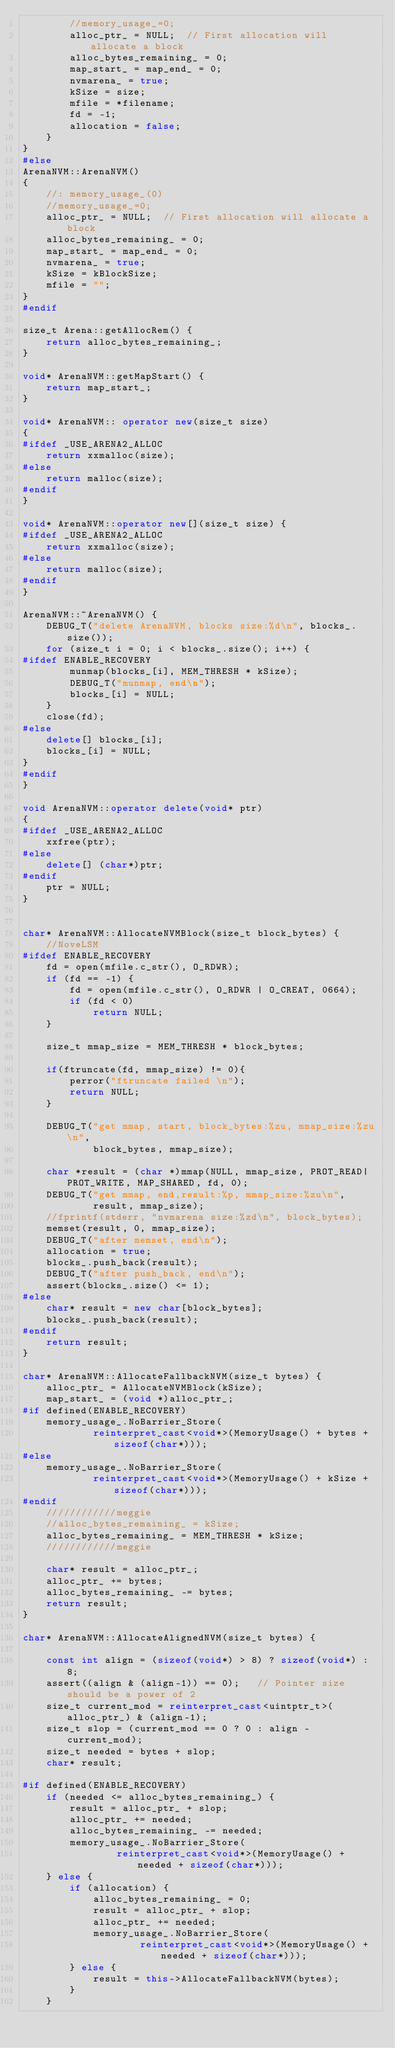<code> <loc_0><loc_0><loc_500><loc_500><_C++_>        //memory_usage_=0;
        alloc_ptr_ = NULL;  // First allocation will allocate a block
        alloc_bytes_remaining_ = 0;
        map_start_ = map_end_ = 0;
        nvmarena_ = true;
        kSize = size;
        mfile = *filename;
        fd = -1;
        allocation = false;
    }
}
#else
ArenaNVM::ArenaNVM()
{
    //: memory_usage_(0)
    //memory_usage_=0;
    alloc_ptr_ = NULL;  // First allocation will allocate a block
    alloc_bytes_remaining_ = 0;
    map_start_ = map_end_ = 0;
    nvmarena_ = true;
    kSize = kBlockSize;
    mfile = "";
}
#endif

size_t Arena::getAllocRem() {
    return alloc_bytes_remaining_;
}

void* ArenaNVM::getMapStart() {
    return map_start_;
}

void* ArenaNVM:: operator new(size_t size)
{
#ifdef _USE_ARENA2_ALLOC
    return xxmalloc(size);
#else
    return malloc(size);
#endif
}

void* ArenaNVM::operator new[](size_t size) {
#ifdef _USE_ARENA2_ALLOC
    return xxmalloc(size);
#else
    return malloc(size);
#endif
}

ArenaNVM::~ArenaNVM() {
    DEBUG_T("delete ArenaNVM, blocks size:%d\n", blocks_.size());
    for (size_t i = 0; i < blocks_.size(); i++) {
#ifdef ENABLE_RECOVERY
        munmap(blocks_[i], MEM_THRESH * kSize);
        DEBUG_T("munmap, end\n");
        blocks_[i] = NULL;
    }
    close(fd);
#else
    delete[] blocks_[i];
    blocks_[i] = NULL;
}
#endif
}

void ArenaNVM::operator delete(void* ptr)
{
#ifdef _USE_ARENA2_ALLOC
    xxfree(ptr);
#else
    delete[] (char*)ptr;
#endif
    ptr = NULL;
}


char* ArenaNVM::AllocateNVMBlock(size_t block_bytes) {
    //NoveLSM
#ifdef ENABLE_RECOVERY
    fd = open(mfile.c_str(), O_RDWR);
    if (fd == -1) {
        fd = open(mfile.c_str(), O_RDWR | O_CREAT, 0664);
        if (fd < 0)
            return NULL;
    }

    size_t mmap_size = MEM_THRESH * block_bytes;
    
    if(ftruncate(fd, mmap_size) != 0){
        perror("ftruncate failed \n");
        return NULL;
    }

    DEBUG_T("get mmap, start, block_bytes:%zu, mmap_size:%zu\n",
            block_bytes, mmap_size);

    char *result = (char *)mmap(NULL, mmap_size, PROT_READ|PROT_WRITE, MAP_SHARED, fd, 0);
    DEBUG_T("get mmap, end,result:%p, mmap_size:%zu\n", 
            result, mmap_size);
    //fprintf(stderr, "nvmarena size:%zd\n", block_bytes);
    memset(result, 0, mmap_size);
    DEBUG_T("after memset, end\n");
    allocation = true;
    blocks_.push_back(result);
    DEBUG_T("after push_back, end\n");
    assert(blocks_.size() <= 1);
#else
    char* result = new char[block_bytes];
    blocks_.push_back(result);
#endif
    return result;
}

char* ArenaNVM::AllocateFallbackNVM(size_t bytes) {
    alloc_ptr_ = AllocateNVMBlock(kSize);
    map_start_ = (void *)alloc_ptr_;
#if defined(ENABLE_RECOVERY)
    memory_usage_.NoBarrier_Store(
            reinterpret_cast<void*>(MemoryUsage() + bytes + sizeof(char*)));
#else
    memory_usage_.NoBarrier_Store(
            reinterpret_cast<void*>(MemoryUsage() + kSize + sizeof(char*)));
#endif
    ////////////meggie
    //alloc_bytes_remaining_ = kSize;
    alloc_bytes_remaining_ = MEM_THRESH * kSize;
    ////////////meggie

    char* result = alloc_ptr_;
    alloc_ptr_ += bytes;
    alloc_bytes_remaining_ -= bytes;
    return result;
}

char* ArenaNVM::AllocateAlignedNVM(size_t bytes) {

    const int align = (sizeof(void*) > 8) ? sizeof(void*) : 8;
    assert((align & (align-1)) == 0);   // Pointer size should be a power of 2
    size_t current_mod = reinterpret_cast<uintptr_t>(alloc_ptr_) & (align-1);
    size_t slop = (current_mod == 0 ? 0 : align - current_mod);
    size_t needed = bytes + slop;
    char* result;

#if defined(ENABLE_RECOVERY)
    if (needed <= alloc_bytes_remaining_) {
        result = alloc_ptr_ + slop;
        alloc_ptr_ += needed;
        alloc_bytes_remaining_ -= needed;
        memory_usage_.NoBarrier_Store(
                reinterpret_cast<void*>(MemoryUsage() + needed + sizeof(char*)));
    } else {
        if (allocation) {
            alloc_bytes_remaining_ = 0;
            result = alloc_ptr_ + slop;
            alloc_ptr_ += needed;
            memory_usage_.NoBarrier_Store(
                    reinterpret_cast<void*>(MemoryUsage() + needed + sizeof(char*)));
        } else {
            result = this->AllocateFallbackNVM(bytes);
        }
    }</code> 